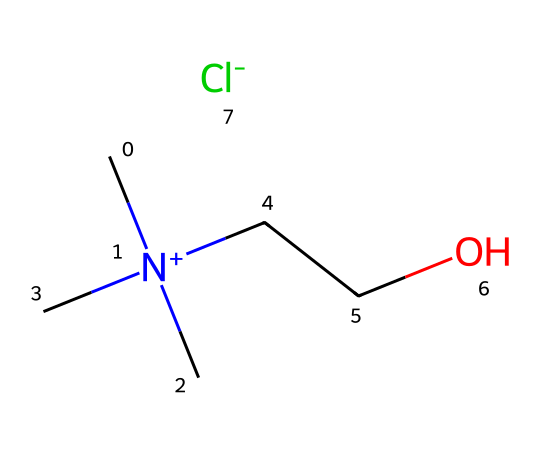What is the ion present in this ionic liquid? The chemical contains a chloride ion as indicated by the presence of the `[Cl-]` notation in the structure, which represents the anion in this ionic liquid.
Answer: chloride How many nitrogen atoms are in the structure? The SMILES representation includes one nitrogen atom represented by `N+`, which indicates the quaternary ammonium part of the ionic liquid.
Answer: one What type of bond connects the carbon atoms in this structure? The carbon atoms in this ionic liquid structure are connected by single (sigma) bonds, as indicated by the absence of any multiple bond notation (like '=', which represents double bonds).
Answer: single How many carbon atoms are present in this molecule? By analyzing the SMILES notation, there are six carbon atoms, derived from both the main chain and the methyl groups connected to the nitrogen.
Answer: six What role does the nitrogen play in this chemical? The nitrogen in the structure acts as a quaternary ammonium ion, which is critical for the ionic character and solubility of this ionic liquid, enhancing its potential use in various applications, including antimicrobial effects.
Answer: quaternary ammonium What property of this ionic liquid might contribute to its antimicrobial activity? The presence of the positively charged quaternary ammonium nitrogen can disrupt microbial cell membranes, which is a significant pathway for antimicrobial activity.
Answer: disrupt cell membranes What is the significance of the hydrophilic group in this structure? The ethyl chain (`CCO`) connected to the nitrogen provides hydrophilic characteristics, which are essential for solubility in water and may enhance interaction with microbial cells.
Answer: enhances solubility 